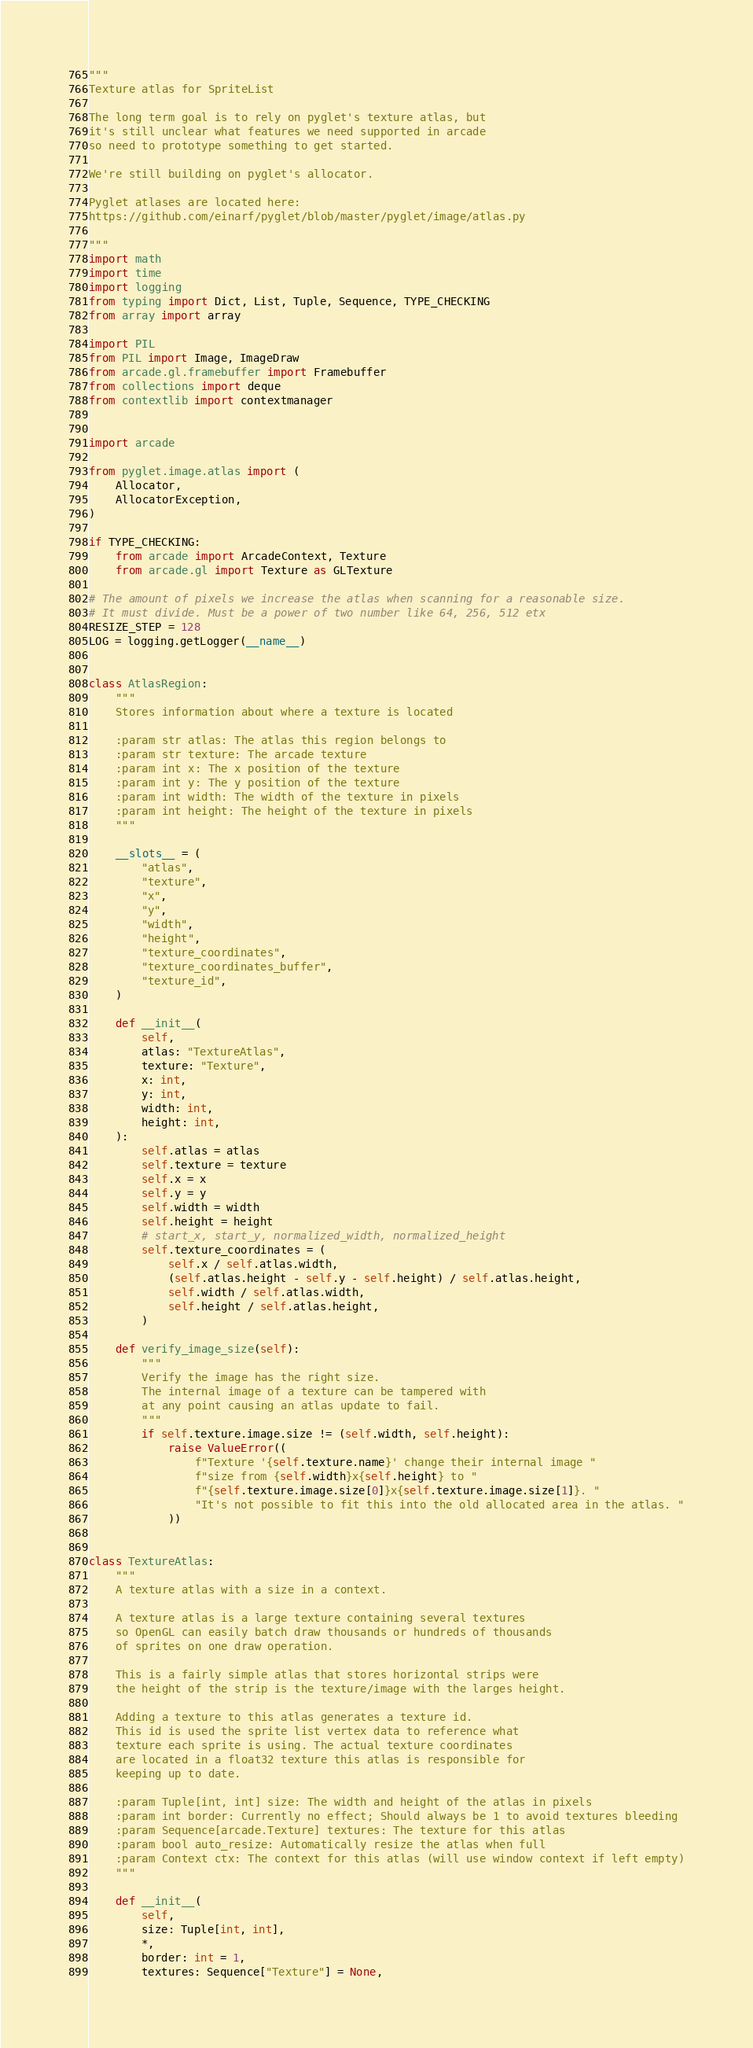Convert code to text. <code><loc_0><loc_0><loc_500><loc_500><_Python_>"""
Texture atlas for SpriteList

The long term goal is to rely on pyglet's texture atlas, but
it's still unclear what features we need supported in arcade
so need to prototype something to get started.

We're still building on pyglet's allocator.

Pyglet atlases are located here:
https://github.com/einarf/pyglet/blob/master/pyglet/image/atlas.py

"""
import math
import time
import logging
from typing import Dict, List, Tuple, Sequence, TYPE_CHECKING
from array import array

import PIL
from PIL import Image, ImageDraw
from arcade.gl.framebuffer import Framebuffer
from collections import deque
from contextlib import contextmanager


import arcade

from pyglet.image.atlas import (
    Allocator,
    AllocatorException,
)

if TYPE_CHECKING:
    from arcade import ArcadeContext, Texture
    from arcade.gl import Texture as GLTexture

# The amount of pixels we increase the atlas when scanning for a reasonable size.
# It must divide. Must be a power of two number like 64, 256, 512 etx
RESIZE_STEP = 128
LOG = logging.getLogger(__name__)


class AtlasRegion:
    """
    Stores information about where a texture is located

    :param str atlas: The atlas this region belongs to
    :param str texture: The arcade texture
    :param int x: The x position of the texture
    :param int y: The y position of the texture
    :param int width: The width of the texture in pixels
    :param int height: The height of the texture in pixels
    """

    __slots__ = (
        "atlas",
        "texture",
        "x",
        "y",
        "width",
        "height",
        "texture_coordinates",
        "texture_coordinates_buffer",
        "texture_id",
    )

    def __init__(
        self,
        atlas: "TextureAtlas",
        texture: "Texture",
        x: int,
        y: int,
        width: int,
        height: int,
    ):
        self.atlas = atlas
        self.texture = texture
        self.x = x
        self.y = y
        self.width = width
        self.height = height
        # start_x, start_y, normalized_width, normalized_height
        self.texture_coordinates = (
            self.x / self.atlas.width,
            (self.atlas.height - self.y - self.height) / self.atlas.height,
            self.width / self.atlas.width,
            self.height / self.atlas.height,
        )

    def verify_image_size(self):
        """
        Verify the image has the right size.
        The internal image of a texture can be tampered with
        at any point causing an atlas update to fail.
        """
        if self.texture.image.size != (self.width, self.height):
            raise ValueError((
                f"Texture '{self.texture.name}' change their internal image "
                f"size from {self.width}x{self.height} to "
                f"{self.texture.image.size[0]}x{self.texture.image.size[1]}. "
                "It's not possible to fit this into the old allocated area in the atlas. "
            ))


class TextureAtlas:
    """
    A texture atlas with a size in a context.

    A texture atlas is a large texture containing several textures
    so OpenGL can easily batch draw thousands or hundreds of thousands
    of sprites on one draw operation.

    This is a fairly simple atlas that stores horizontal strips were
    the height of the strip is the texture/image with the larges height.

    Adding a texture to this atlas generates a texture id.
    This id is used the sprite list vertex data to reference what
    texture each sprite is using. The actual texture coordinates
    are located in a float32 texture this atlas is responsible for
    keeping up to date.

    :param Tuple[int, int] size: The width and height of the atlas in pixels
    :param int border: Currently no effect; Should always be 1 to avoid textures bleeding
    :param Sequence[arcade.Texture] textures: The texture for this atlas
    :param bool auto_resize: Automatically resize the atlas when full
    :param Context ctx: The context for this atlas (will use window context if left empty)
    """

    def __init__(
        self,
        size: Tuple[int, int],
        *,
        border: int = 1,
        textures: Sequence["Texture"] = None,</code> 